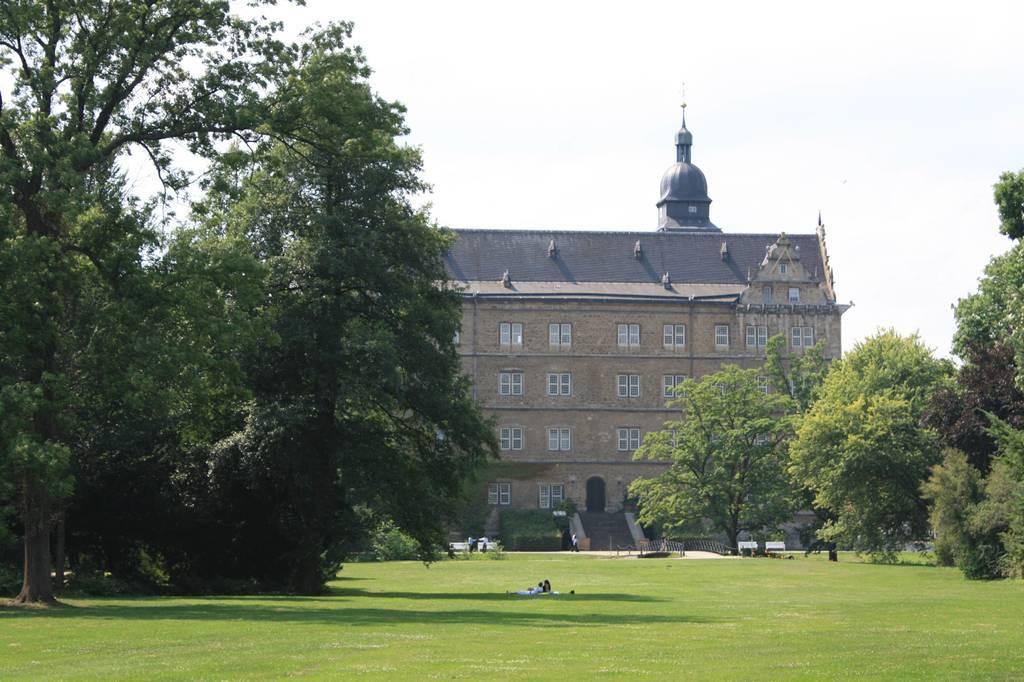What type of outdoor space is depicted in the image? There is a garden in the image. What can be seen on both sides of the garden? Trees are present on both the left and right sides of the image. What is visible in the background of the garden? There is a building and the sky in the background of the image. How many hydrants are visible in the garden? There are no hydrants present in the garden; it is a garden with trees and a background with a building and sky. Where are the babies playing in the garden? There are no babies present in the garden; it only contains a garden, trees, and a background with a building and sky. 